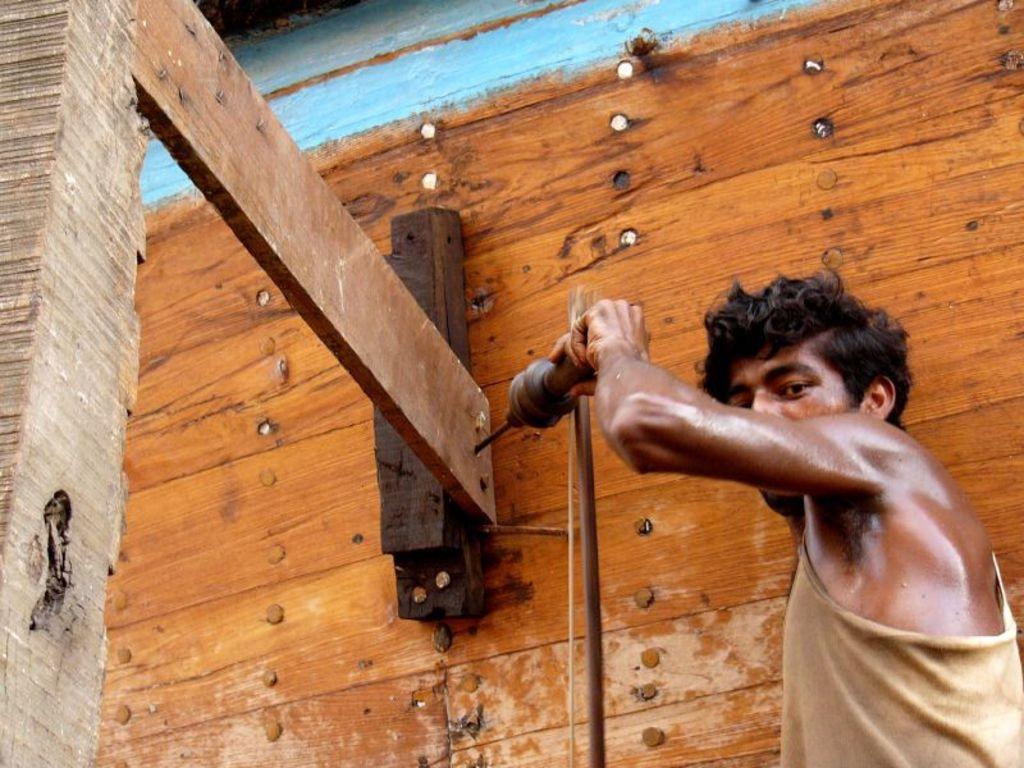What is the main subject of the image? There is a person in the image. Where is the person located in the image? The person is standing on the right side. What is the person holding in the image? The person is holding a drilling machine. What other objects can be seen in the image? There is a piece of wood in the image. Can you describe the background of the image? The wooden background has screws. What type of pie is the person holding in the image? There is no pie present in the image; the person is holding a drilling machine. Can you tell me how many pigs are visible in the image? There are no pigs visible in the image. 